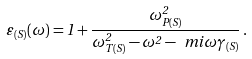Convert formula to latex. <formula><loc_0><loc_0><loc_500><loc_500>\varepsilon _ { ( S ) } ( \omega ) = 1 + \frac { \omega _ { P ( S ) } ^ { 2 } } { \omega _ { T ( S ) } ^ { 2 } - \omega ^ { 2 } - \ m i \omega \gamma _ { ( S ) } } \, .</formula> 